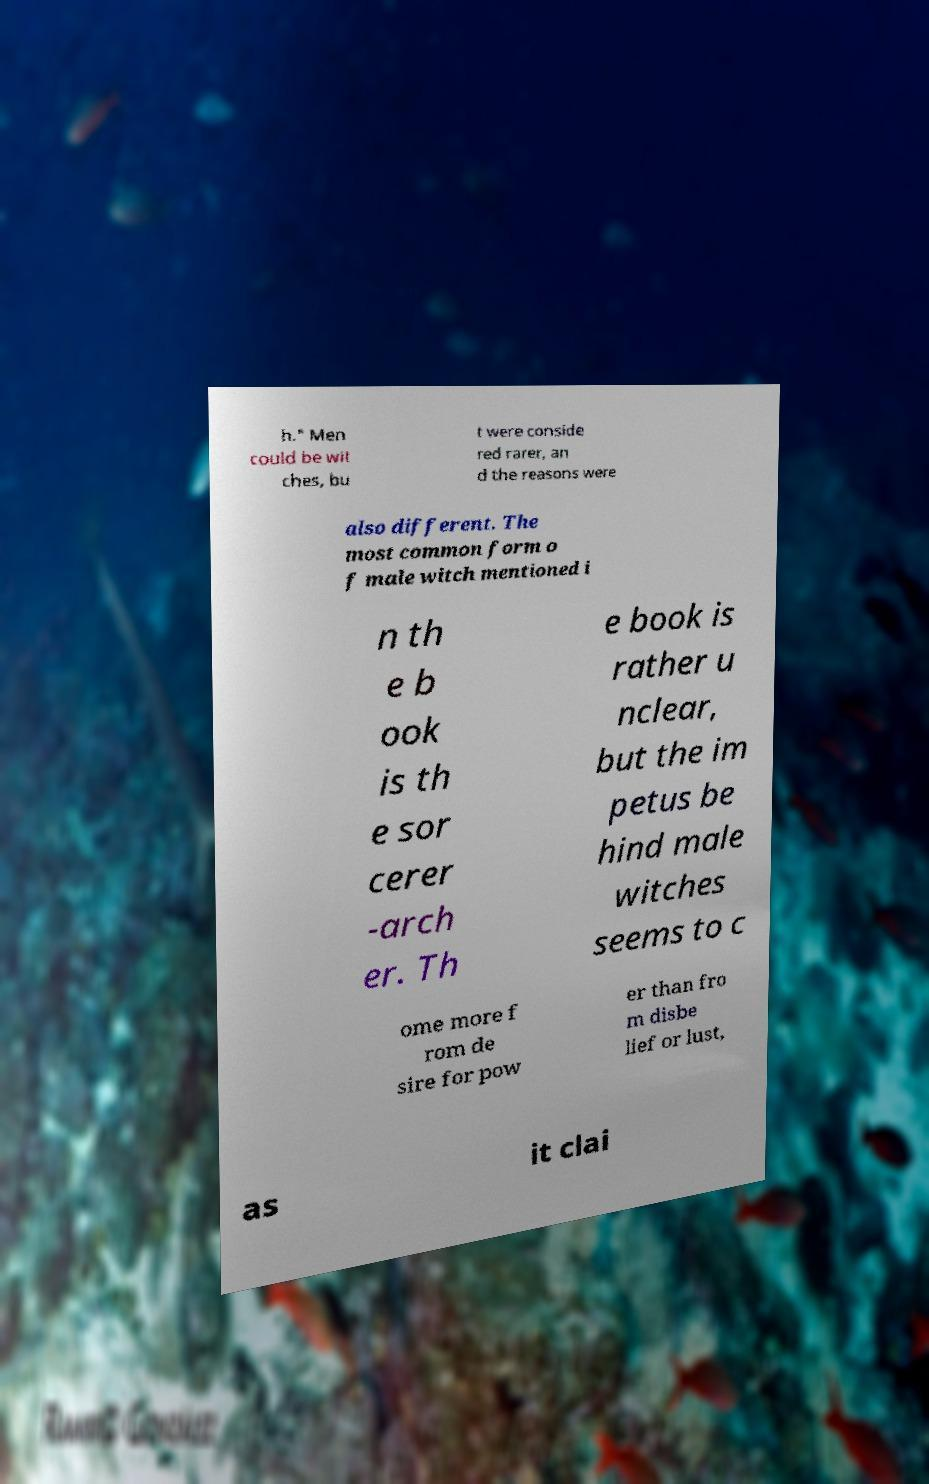Please read and relay the text visible in this image. What does it say? h." Men could be wit ches, bu t were conside red rarer, an d the reasons were also different. The most common form o f male witch mentioned i n th e b ook is th e sor cerer -arch er. Th e book is rather u nclear, but the im petus be hind male witches seems to c ome more f rom de sire for pow er than fro m disbe lief or lust, as it clai 